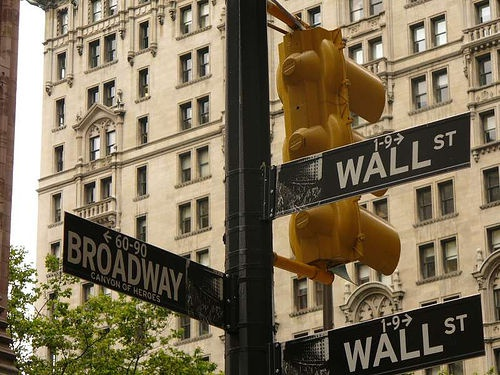Describe the objects in this image and their specific colors. I can see a traffic light in black, maroon, and olive tones in this image. 